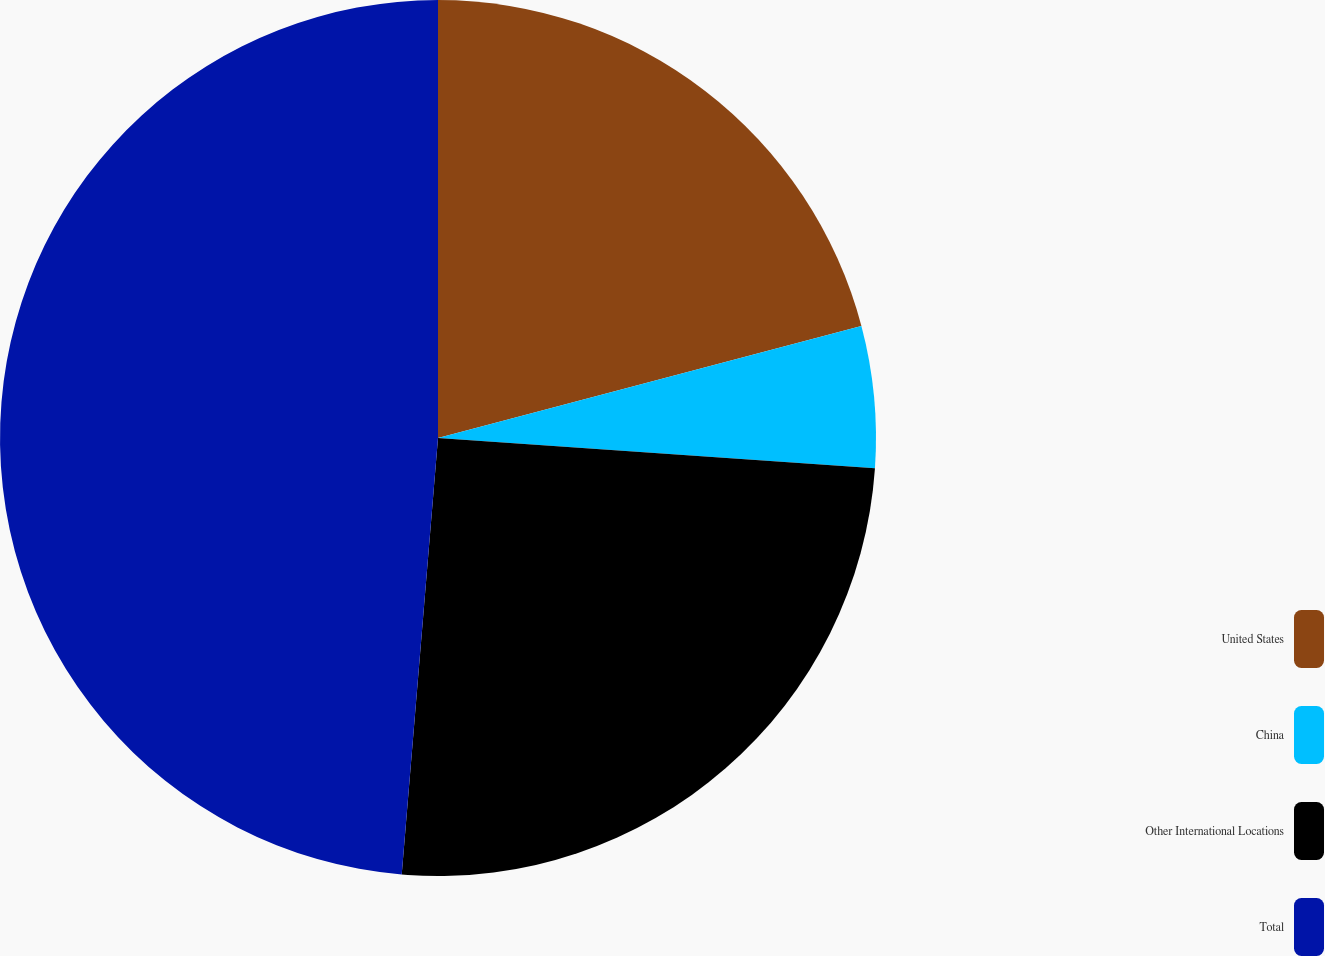<chart> <loc_0><loc_0><loc_500><loc_500><pie_chart><fcel>United States<fcel>China<fcel>Other International Locations<fcel>Total<nl><fcel>20.88%<fcel>5.22%<fcel>25.22%<fcel>48.68%<nl></chart> 